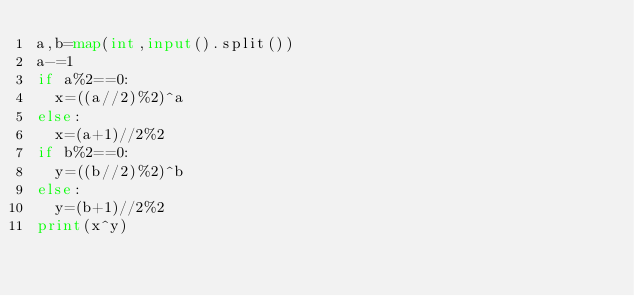<code> <loc_0><loc_0><loc_500><loc_500><_Python_>a,b=map(int,input().split())
a-=1
if a%2==0:
	x=((a//2)%2)^a
else:
	x=(a+1)//2%2
if b%2==0:
	y=((b//2)%2)^b
else:
	y=(b+1)//2%2
print(x^y)
</code> 